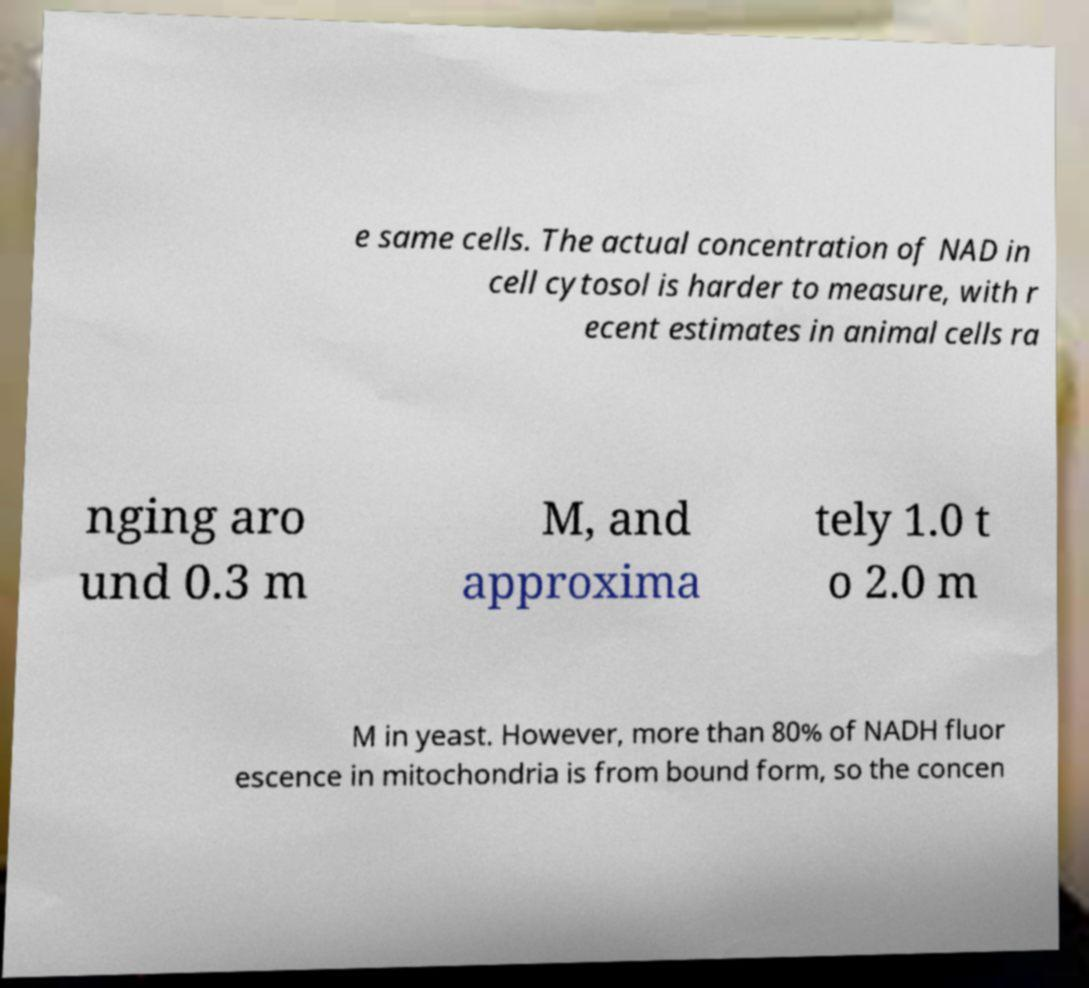Can you read and provide the text displayed in the image?This photo seems to have some interesting text. Can you extract and type it out for me? e same cells. The actual concentration of NAD in cell cytosol is harder to measure, with r ecent estimates in animal cells ra nging aro und 0.3 m M, and approxima tely 1.0 t o 2.0 m M in yeast. However, more than 80% of NADH fluor escence in mitochondria is from bound form, so the concen 